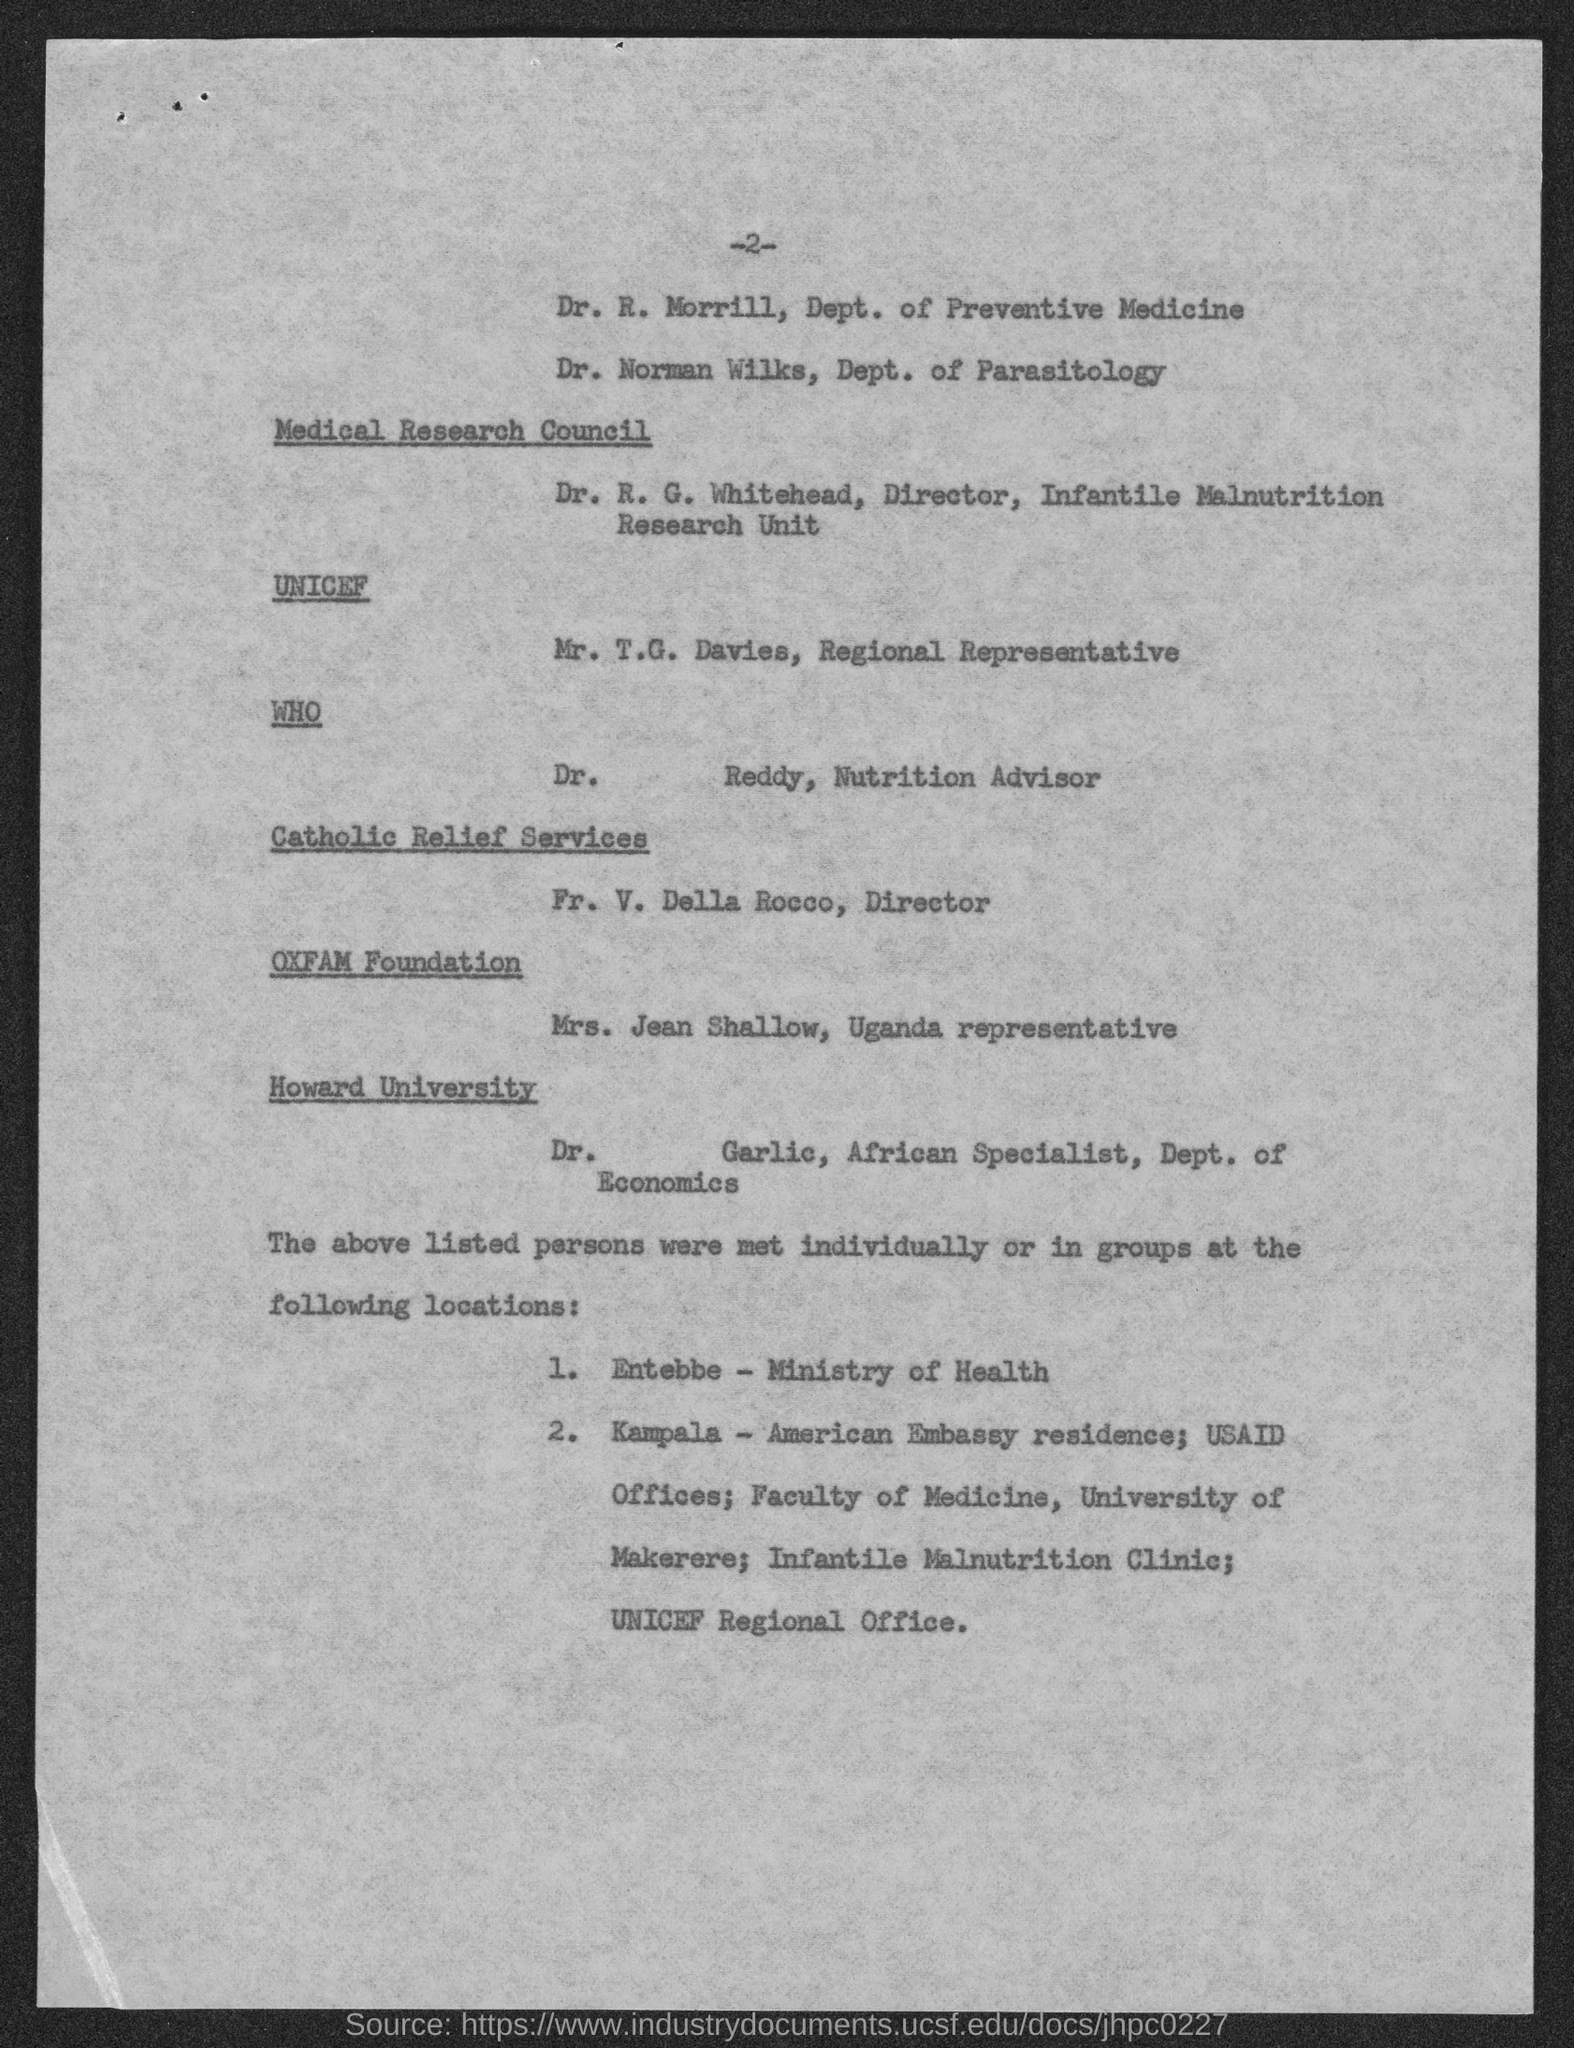What is the number at top of the page ?
Give a very brief answer. 2. To which department does dr. r. morrill ?
Your answer should be very brief. Dept. of Preventive Medicine. What is the position of dr. r.g. whitehead?
Your answer should be very brief. Director, Infantile Malnutrition Research Unit. What is the position of mr. t.g. davies?
Provide a succinct answer. Regional Representative. What is the position of dr. reddy ?
Offer a terse response. Nutrition Advisor. What is the position of fr. v. della rocco ?
Ensure brevity in your answer.  Director. What is the position of mrs. jean shallow?
Make the answer very short. Uganda representative. 